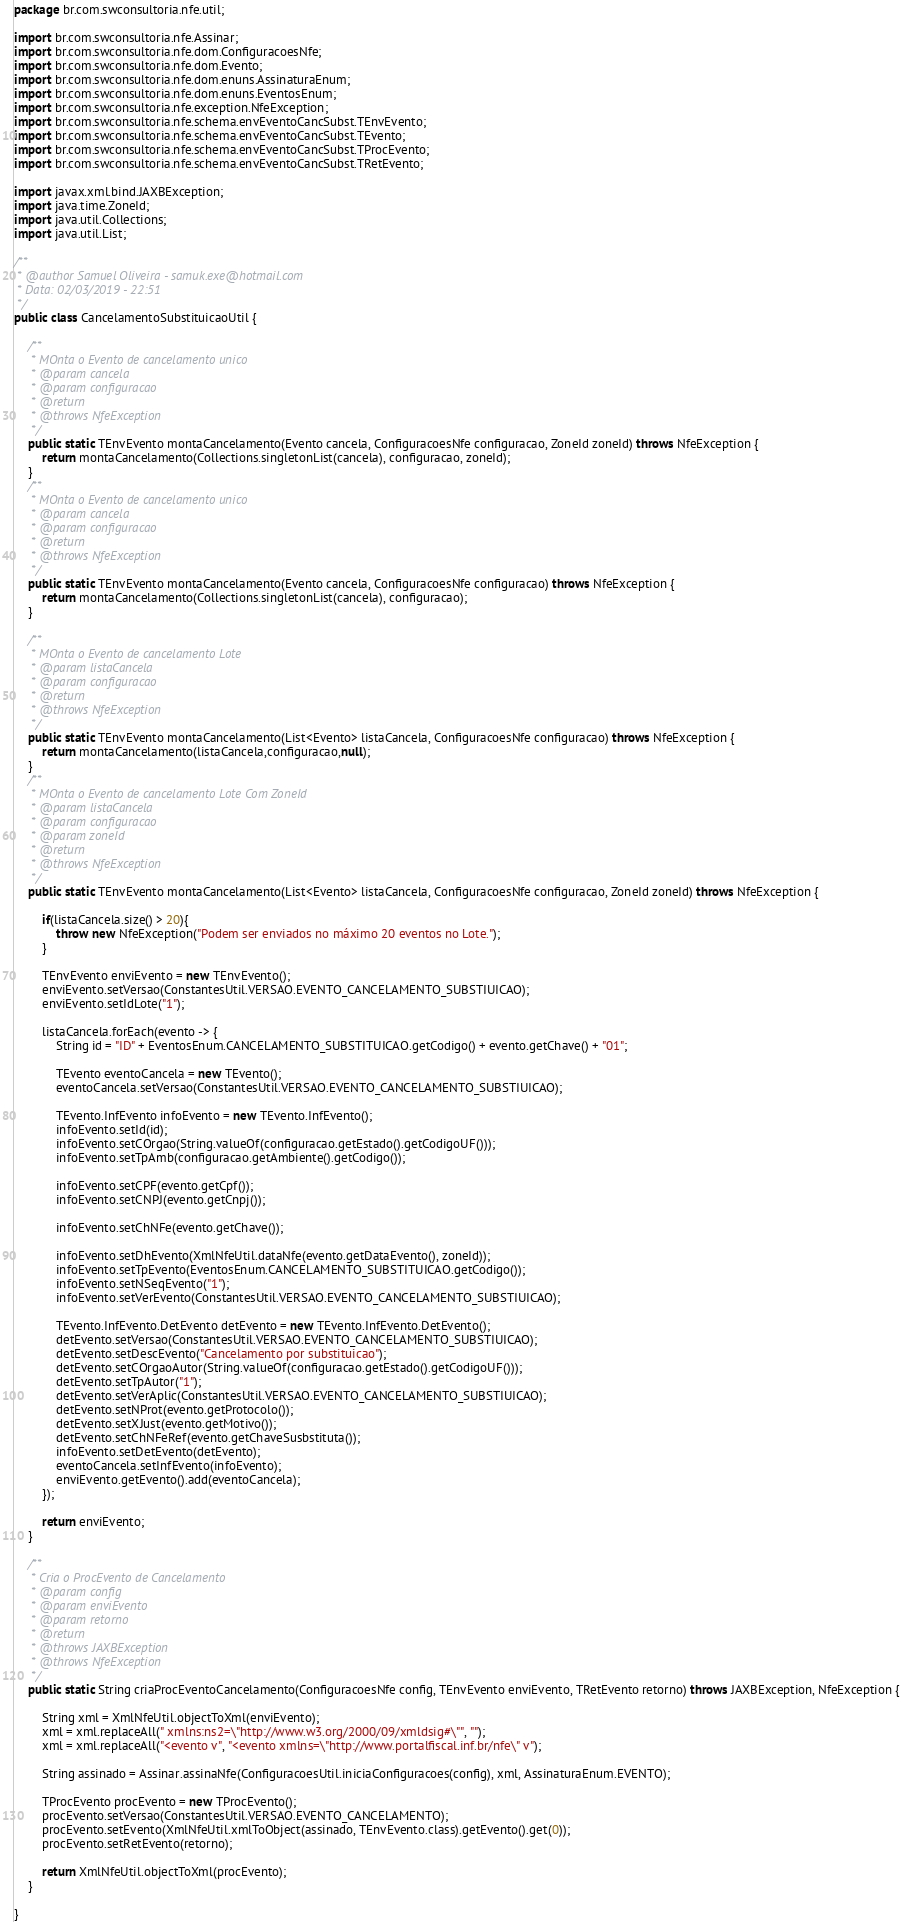Convert code to text. <code><loc_0><loc_0><loc_500><loc_500><_Java_>package br.com.swconsultoria.nfe.util;

import br.com.swconsultoria.nfe.Assinar;
import br.com.swconsultoria.nfe.dom.ConfiguracoesNfe;
import br.com.swconsultoria.nfe.dom.Evento;
import br.com.swconsultoria.nfe.dom.enuns.AssinaturaEnum;
import br.com.swconsultoria.nfe.dom.enuns.EventosEnum;
import br.com.swconsultoria.nfe.exception.NfeException;
import br.com.swconsultoria.nfe.schema.envEventoCancSubst.TEnvEvento;
import br.com.swconsultoria.nfe.schema.envEventoCancSubst.TEvento;
import br.com.swconsultoria.nfe.schema.envEventoCancSubst.TProcEvento;
import br.com.swconsultoria.nfe.schema.envEventoCancSubst.TRetEvento;

import javax.xml.bind.JAXBException;
import java.time.ZoneId;
import java.util.Collections;
import java.util.List;

/**
 * @author Samuel Oliveira - samuk.exe@hotmail.com
 * Data: 02/03/2019 - 22:51
 */
public class CancelamentoSubstituicaoUtil {

    /**
     * MOnta o Evento de cancelamento unico
     * @param cancela
     * @param configuracao
     * @return
     * @throws NfeException
     */
    public static TEnvEvento montaCancelamento(Evento cancela, ConfiguracoesNfe configuracao, ZoneId zoneId) throws NfeException {
        return montaCancelamento(Collections.singletonList(cancela), configuracao, zoneId);
    }
    /**
     * MOnta o Evento de cancelamento unico
     * @param cancela
     * @param configuracao
     * @return
     * @throws NfeException
     */
    public static TEnvEvento montaCancelamento(Evento cancela, ConfiguracoesNfe configuracao) throws NfeException {
        return montaCancelamento(Collections.singletonList(cancela), configuracao);
    }

    /**
     * MOnta o Evento de cancelamento Lote
     * @param listaCancela
     * @param configuracao
     * @return
     * @throws NfeException
     */
    public static TEnvEvento montaCancelamento(List<Evento> listaCancela, ConfiguracoesNfe configuracao) throws NfeException {
        return montaCancelamento(listaCancela,configuracao,null);
    }
    /**
     * MOnta o Evento de cancelamento Lote Com ZoneId
     * @param listaCancela
     * @param configuracao
     * @param zoneId
     * @return
     * @throws NfeException
     */
    public static TEnvEvento montaCancelamento(List<Evento> listaCancela, ConfiguracoesNfe configuracao, ZoneId zoneId) throws NfeException {

        if(listaCancela.size() > 20){
            throw new NfeException("Podem ser enviados no máximo 20 eventos no Lote.");
        }

        TEnvEvento enviEvento = new TEnvEvento();
        enviEvento.setVersao(ConstantesUtil.VERSAO.EVENTO_CANCELAMENTO_SUBSTIUICAO);
        enviEvento.setIdLote("1");

        listaCancela.forEach(evento -> {
            String id = "ID" + EventosEnum.CANCELAMENTO_SUBSTITUICAO.getCodigo() + evento.getChave() + "01";

            TEvento eventoCancela = new TEvento();
            eventoCancela.setVersao(ConstantesUtil.VERSAO.EVENTO_CANCELAMENTO_SUBSTIUICAO);

            TEvento.InfEvento infoEvento = new TEvento.InfEvento();
            infoEvento.setId(id);
            infoEvento.setCOrgao(String.valueOf(configuracao.getEstado().getCodigoUF()));
            infoEvento.setTpAmb(configuracao.getAmbiente().getCodigo());

            infoEvento.setCPF(evento.getCpf());
            infoEvento.setCNPJ(evento.getCnpj());

            infoEvento.setChNFe(evento.getChave());

            infoEvento.setDhEvento(XmlNfeUtil.dataNfe(evento.getDataEvento(), zoneId));
            infoEvento.setTpEvento(EventosEnum.CANCELAMENTO_SUBSTITUICAO.getCodigo());
            infoEvento.setNSeqEvento("1");
            infoEvento.setVerEvento(ConstantesUtil.VERSAO.EVENTO_CANCELAMENTO_SUBSTIUICAO);

            TEvento.InfEvento.DetEvento detEvento = new TEvento.InfEvento.DetEvento();
            detEvento.setVersao(ConstantesUtil.VERSAO.EVENTO_CANCELAMENTO_SUBSTIUICAO);
            detEvento.setDescEvento("Cancelamento por substituicao");
            detEvento.setCOrgaoAutor(String.valueOf(configuracao.getEstado().getCodigoUF()));
            detEvento.setTpAutor("1");
            detEvento.setVerAplic(ConstantesUtil.VERSAO.EVENTO_CANCELAMENTO_SUBSTIUICAO);
            detEvento.setNProt(evento.getProtocolo());
            detEvento.setXJust(evento.getMotivo());
            detEvento.setChNFeRef(evento.getChaveSusbstituta());
            infoEvento.setDetEvento(detEvento);
            eventoCancela.setInfEvento(infoEvento);
            enviEvento.getEvento().add(eventoCancela);
        });

        return enviEvento;
    }

    /**
     * Cria o ProcEvento de Cancelamento
     * @param config
     * @param enviEvento
     * @param retorno
     * @return
     * @throws JAXBException
     * @throws NfeException
     */
    public static String criaProcEventoCancelamento(ConfiguracoesNfe config, TEnvEvento enviEvento, TRetEvento retorno) throws JAXBException, NfeException {

        String xml = XmlNfeUtil.objectToXml(enviEvento);
        xml = xml.replaceAll(" xmlns:ns2=\"http://www.w3.org/2000/09/xmldsig#\"", "");
        xml = xml.replaceAll("<evento v", "<evento xmlns=\"http://www.portalfiscal.inf.br/nfe\" v");

        String assinado = Assinar.assinaNfe(ConfiguracoesUtil.iniciaConfiguracoes(config), xml, AssinaturaEnum.EVENTO);

        TProcEvento procEvento = new TProcEvento();
        procEvento.setVersao(ConstantesUtil.VERSAO.EVENTO_CANCELAMENTO);
        procEvento.setEvento(XmlNfeUtil.xmlToObject(assinado, TEnvEvento.class).getEvento().get(0));
        procEvento.setRetEvento(retorno);

        return XmlNfeUtil.objectToXml(procEvento);
    }

}
</code> 